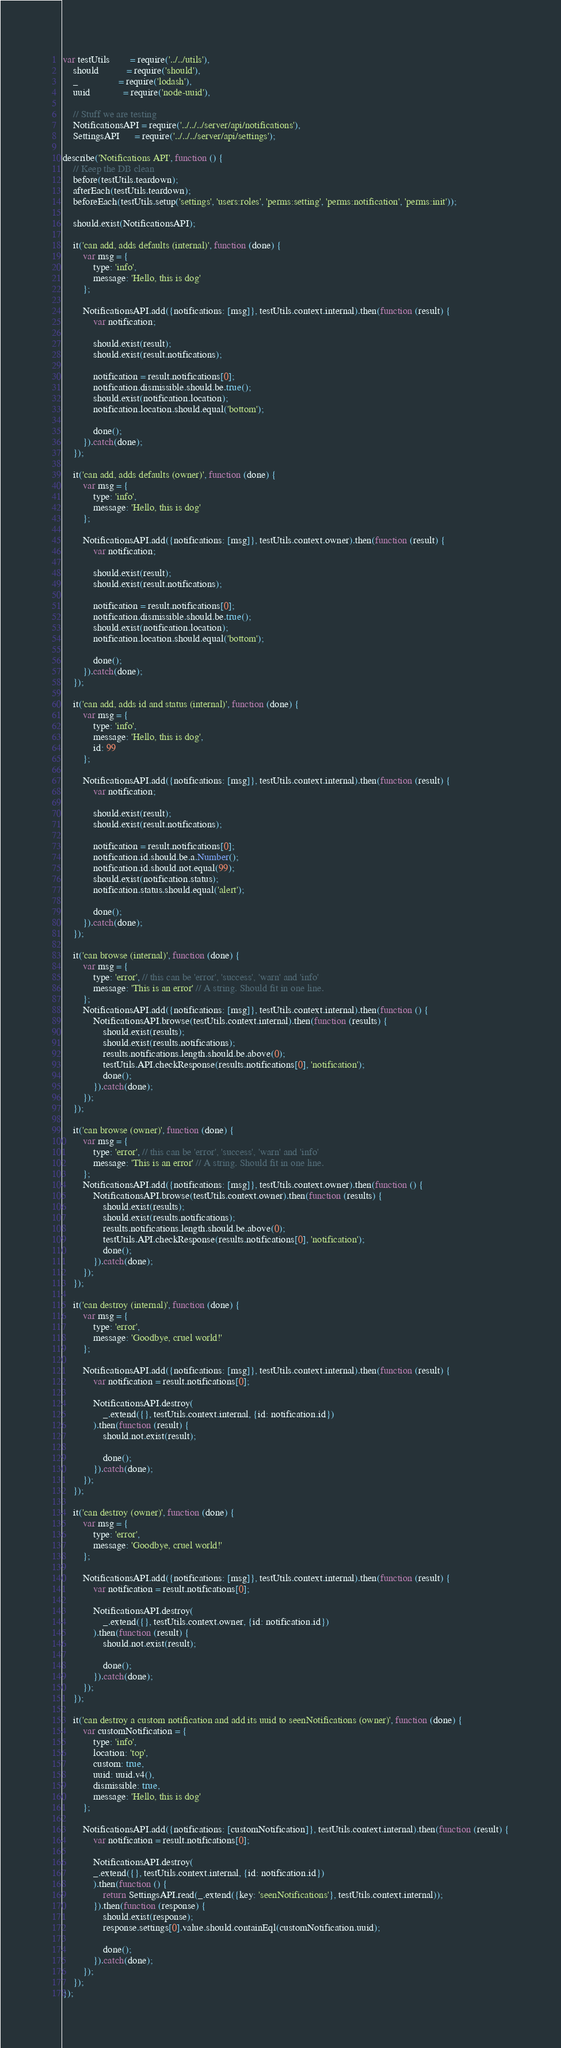<code> <loc_0><loc_0><loc_500><loc_500><_JavaScript_>var testUtils        = require('../../utils'),
    should           = require('should'),
    _                = require('lodash'),
    uuid             = require('node-uuid'),

    // Stuff we are testing
    NotificationsAPI = require('../../../server/api/notifications'),
    SettingsAPI      = require('../../../server/api/settings');

describe('Notifications API', function () {
    // Keep the DB clean
    before(testUtils.teardown);
    afterEach(testUtils.teardown);
    beforeEach(testUtils.setup('settings', 'users:roles', 'perms:setting', 'perms:notification', 'perms:init'));

    should.exist(NotificationsAPI);

    it('can add, adds defaults (internal)', function (done) {
        var msg = {
            type: 'info',
            message: 'Hello, this is dog'
        };

        NotificationsAPI.add({notifications: [msg]}, testUtils.context.internal).then(function (result) {
            var notification;

            should.exist(result);
            should.exist(result.notifications);

            notification = result.notifications[0];
            notification.dismissible.should.be.true();
            should.exist(notification.location);
            notification.location.should.equal('bottom');

            done();
        }).catch(done);
    });

    it('can add, adds defaults (owner)', function (done) {
        var msg = {
            type: 'info',
            message: 'Hello, this is dog'
        };

        NotificationsAPI.add({notifications: [msg]}, testUtils.context.owner).then(function (result) {
            var notification;

            should.exist(result);
            should.exist(result.notifications);

            notification = result.notifications[0];
            notification.dismissible.should.be.true();
            should.exist(notification.location);
            notification.location.should.equal('bottom');

            done();
        }).catch(done);
    });

    it('can add, adds id and status (internal)', function (done) {
        var msg = {
            type: 'info',
            message: 'Hello, this is dog',
            id: 99
        };

        NotificationsAPI.add({notifications: [msg]}, testUtils.context.internal).then(function (result) {
            var notification;

            should.exist(result);
            should.exist(result.notifications);

            notification = result.notifications[0];
            notification.id.should.be.a.Number();
            notification.id.should.not.equal(99);
            should.exist(notification.status);
            notification.status.should.equal('alert');

            done();
        }).catch(done);
    });

    it('can browse (internal)', function (done) {
        var msg = {
            type: 'error', // this can be 'error', 'success', 'warn' and 'info'
            message: 'This is an error' // A string. Should fit in one line.
        };
        NotificationsAPI.add({notifications: [msg]}, testUtils.context.internal).then(function () {
            NotificationsAPI.browse(testUtils.context.internal).then(function (results) {
                should.exist(results);
                should.exist(results.notifications);
                results.notifications.length.should.be.above(0);
                testUtils.API.checkResponse(results.notifications[0], 'notification');
                done();
            }).catch(done);
        });
    });

    it('can browse (owner)', function (done) {
        var msg = {
            type: 'error', // this can be 'error', 'success', 'warn' and 'info'
            message: 'This is an error' // A string. Should fit in one line.
        };
        NotificationsAPI.add({notifications: [msg]}, testUtils.context.owner).then(function () {
            NotificationsAPI.browse(testUtils.context.owner).then(function (results) {
                should.exist(results);
                should.exist(results.notifications);
                results.notifications.length.should.be.above(0);
                testUtils.API.checkResponse(results.notifications[0], 'notification');
                done();
            }).catch(done);
        });
    });

    it('can destroy (internal)', function (done) {
        var msg = {
            type: 'error',
            message: 'Goodbye, cruel world!'
        };

        NotificationsAPI.add({notifications: [msg]}, testUtils.context.internal).then(function (result) {
            var notification = result.notifications[0];

            NotificationsAPI.destroy(
                _.extend({}, testUtils.context.internal, {id: notification.id})
            ).then(function (result) {
                should.not.exist(result);

                done();
            }).catch(done);
        });
    });

    it('can destroy (owner)', function (done) {
        var msg = {
            type: 'error',
            message: 'Goodbye, cruel world!'
        };

        NotificationsAPI.add({notifications: [msg]}, testUtils.context.internal).then(function (result) {
            var notification = result.notifications[0];

            NotificationsAPI.destroy(
                _.extend({}, testUtils.context.owner, {id: notification.id})
            ).then(function (result) {
                should.not.exist(result);

                done();
            }).catch(done);
        });
    });

    it('can destroy a custom notification and add its uuid to seenNotifications (owner)', function (done) {
        var customNotification = {
            type: 'info',
            location: 'top',
            custom: true,
            uuid: uuid.v4(),
            dismissible: true,
            message: 'Hello, this is dog'
        };

        NotificationsAPI.add({notifications: [customNotification]}, testUtils.context.internal).then(function (result) {
            var notification = result.notifications[0];

            NotificationsAPI.destroy(
            _.extend({}, testUtils.context.internal, {id: notification.id})
            ).then(function () {
                return SettingsAPI.read(_.extend({key: 'seenNotifications'}, testUtils.context.internal));
            }).then(function (response) {
                should.exist(response);
                response.settings[0].value.should.containEql(customNotification.uuid);

                done();
            }).catch(done);
        });
    });
});
</code> 